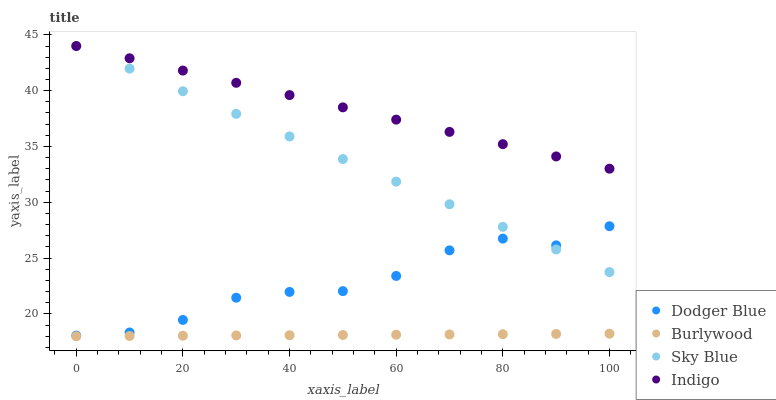Does Burlywood have the minimum area under the curve?
Answer yes or no. Yes. Does Indigo have the maximum area under the curve?
Answer yes or no. Yes. Does Sky Blue have the minimum area under the curve?
Answer yes or no. No. Does Sky Blue have the maximum area under the curve?
Answer yes or no. No. Is Burlywood the smoothest?
Answer yes or no. Yes. Is Dodger Blue the roughest?
Answer yes or no. Yes. Is Sky Blue the smoothest?
Answer yes or no. No. Is Sky Blue the roughest?
Answer yes or no. No. Does Burlywood have the lowest value?
Answer yes or no. Yes. Does Sky Blue have the lowest value?
Answer yes or no. No. Does Indigo have the highest value?
Answer yes or no. Yes. Does Dodger Blue have the highest value?
Answer yes or no. No. Is Burlywood less than Indigo?
Answer yes or no. Yes. Is Dodger Blue greater than Burlywood?
Answer yes or no. Yes. Does Sky Blue intersect Indigo?
Answer yes or no. Yes. Is Sky Blue less than Indigo?
Answer yes or no. No. Is Sky Blue greater than Indigo?
Answer yes or no. No. Does Burlywood intersect Indigo?
Answer yes or no. No. 